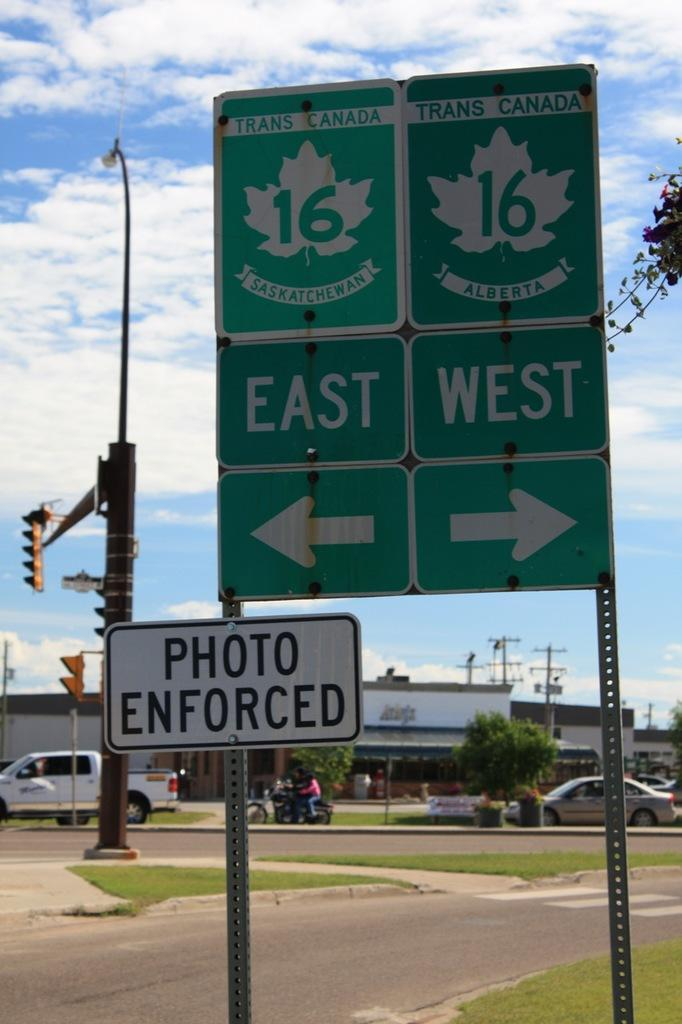What is the main object in the foreground of the image? There is a sign board in the image. What can be seen in the background of the image? There is a road, grassland, signal poles, cars moving, a building, and the sky visible in the background of the image. How many pages of prose are present in the image? There is no prose present in the image; it features a sign board and various elements in the background. What type of nose can be seen on the building in the image? There is no nose present on the building in the image; it is a structure with no facial features. 